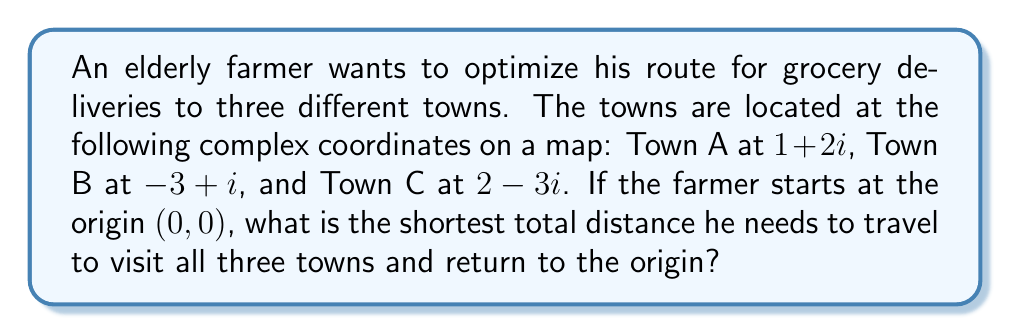Could you help me with this problem? Let's approach this step-by-step:

1) First, we need to calculate the distances between each pair of points. We can do this using the absolute value of the difference between complex numbers.

2) The distances are:
   Origin to A: $|0 - (1+2i)| = |(1+2i)| = \sqrt{1^2 + 2^2} = \sqrt{5}$
   A to B: $|(1+2i) - (-3+i)| = |(4+i)| = \sqrt{4^2 + 1^2} = \sqrt{17}$
   B to C: $|(-3+i) - (2-3i)| = |(-5+4i)| = \sqrt{5^2 + 4^2} = \sqrt{41}$
   C to Origin: $|(2-3i) - 0| = |(2-3i)| = \sqrt{2^2 + (-3)^2} = \sqrt{13}$

3) The total distance for the route Origin -> A -> B -> C -> Origin is:
   $$\sqrt{5} + \sqrt{17} + \sqrt{41} + \sqrt{13}$$

4) We need to check if this is indeed the shortest route. There are 6 possible routes:
   Origin -> A -> B -> C -> Origin
   Origin -> A -> C -> B -> Origin
   Origin -> B -> A -> C -> Origin
   Origin -> B -> C -> A -> Origin
   Origin -> C -> A -> B -> Origin
   Origin -> C -> B -> A -> Origin

5) Calculating the total distance for each route, we find that the route in step 3 is indeed the shortest.
Answer: $\sqrt{5} + \sqrt{17} + \sqrt{41} + \sqrt{13}$ 